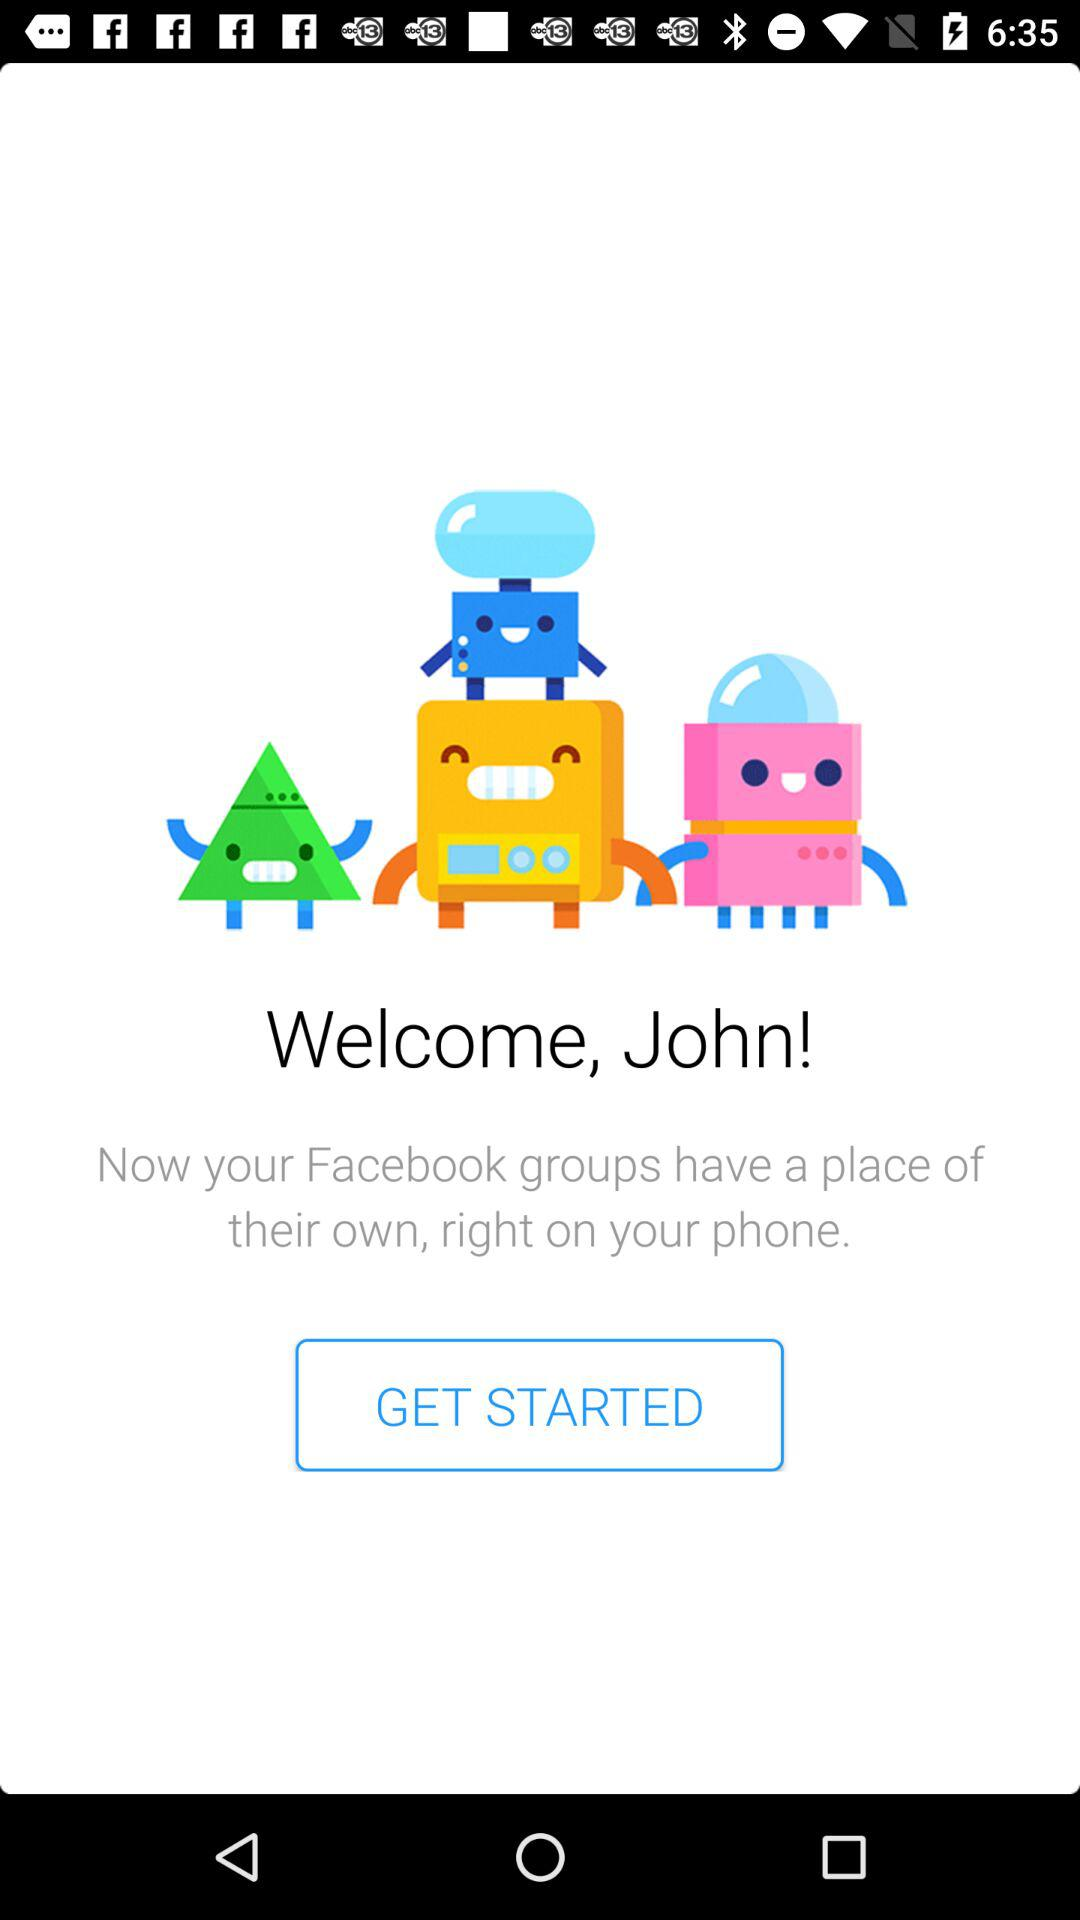What is the name of the user? The name of the user is John. 